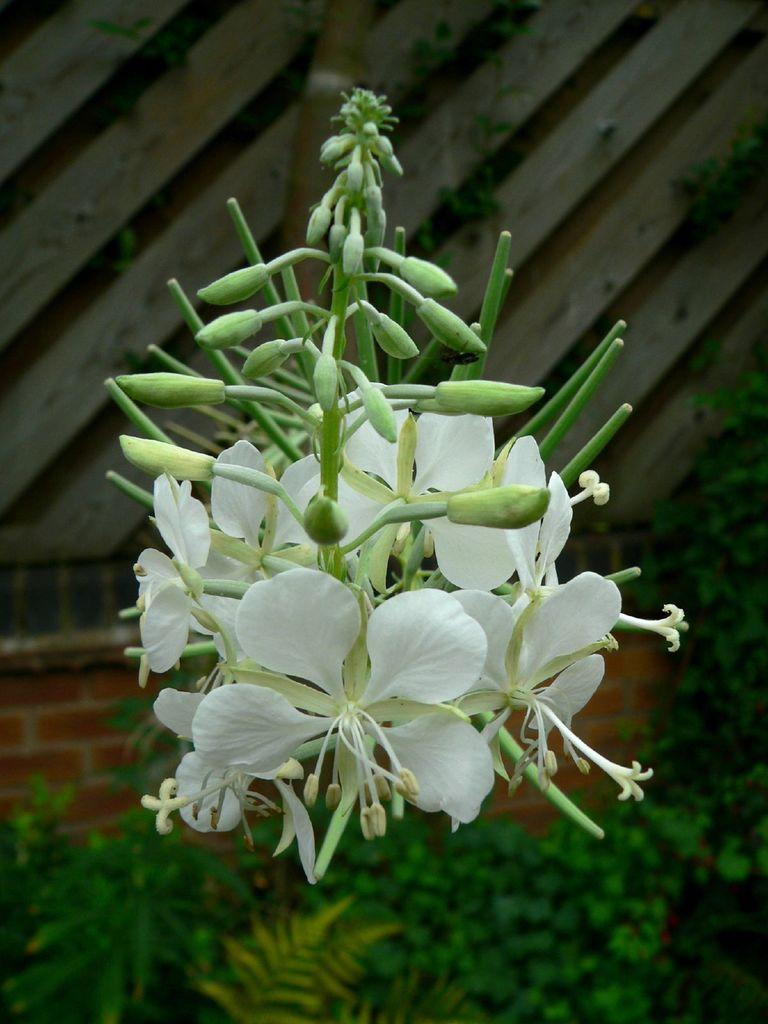What type of living organism is present in the image? There is a plant in the image. What are the reproductive parts of the plant visible in the image? The plant has flowers and buds. What material is used for the wall in the background of the image? There is a wooden wall in the background of the image. Can you see a trail made of plastic in the image? There is no trail made of plastic present in the image. 